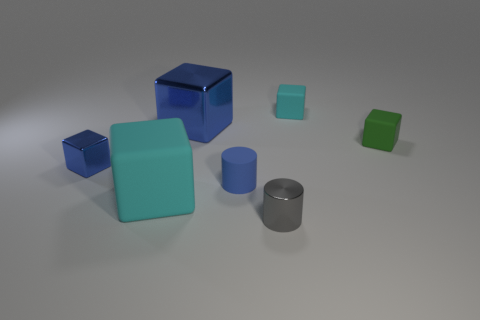Subtract all green cubes. How many cubes are left? 4 Subtract all small cyan matte blocks. How many blocks are left? 4 Add 1 big gray metal cylinders. How many objects exist? 8 Subtract all gray blocks. Subtract all blue balls. How many blocks are left? 5 Subtract all blocks. How many objects are left? 2 Add 4 tiny blue cubes. How many tiny blue cubes exist? 5 Subtract 0 gray spheres. How many objects are left? 7 Subtract all small cyan shiny things. Subtract all blue cylinders. How many objects are left? 6 Add 6 tiny blocks. How many tiny blocks are left? 9 